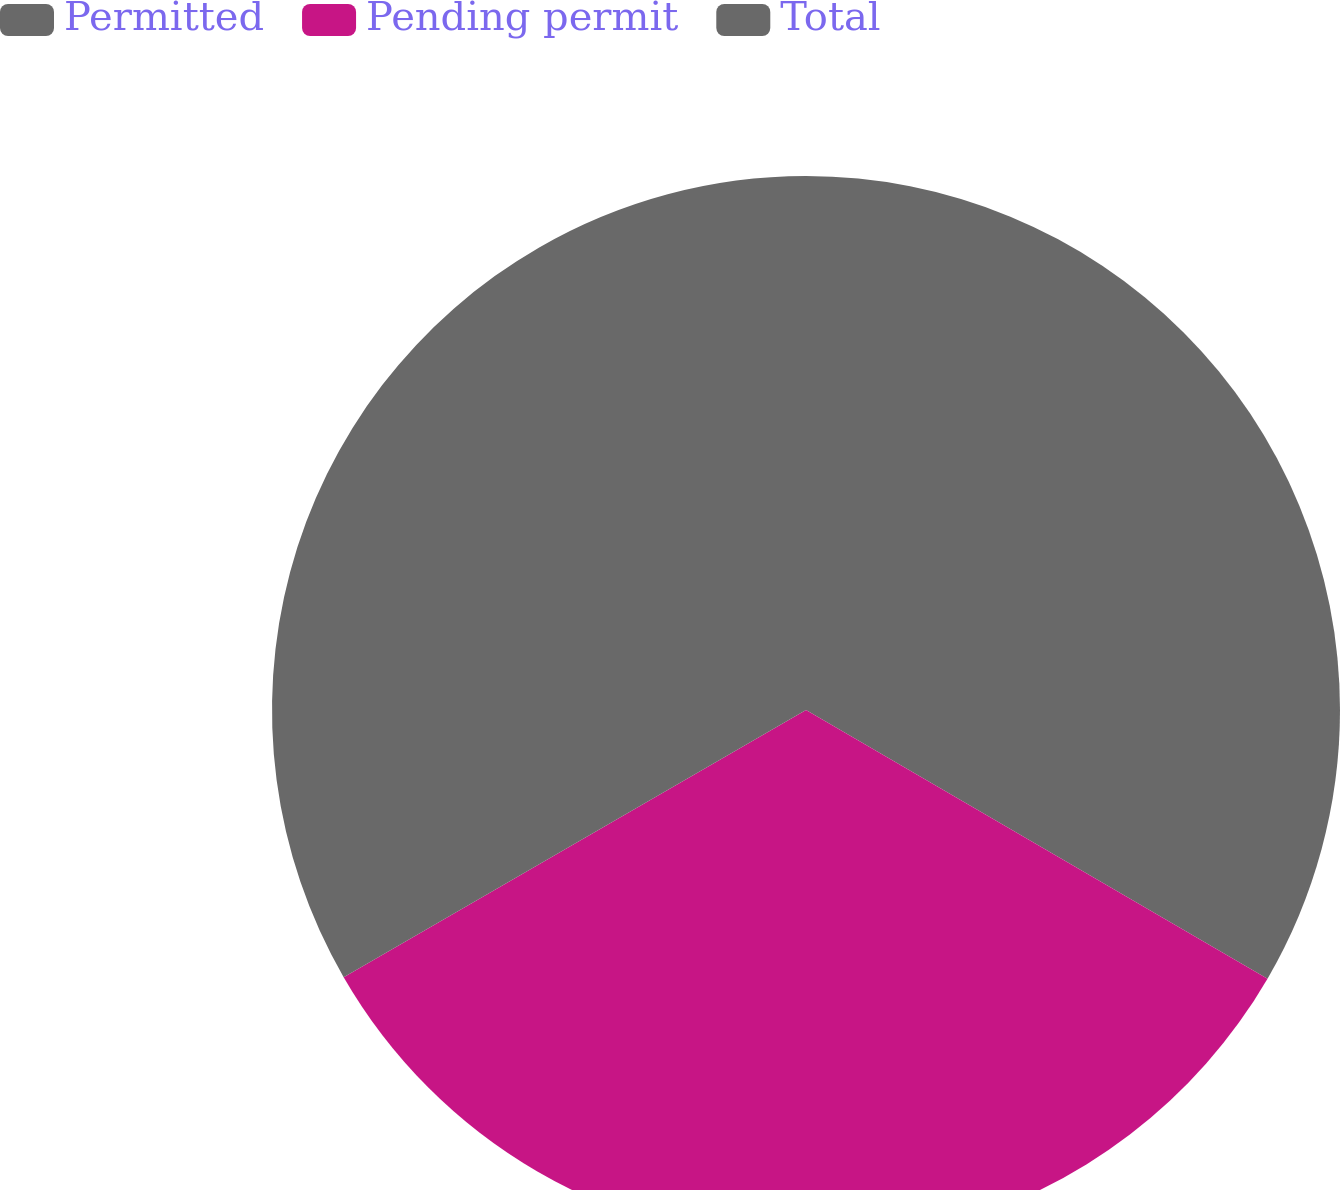Convert chart. <chart><loc_0><loc_0><loc_500><loc_500><pie_chart><fcel>Permitted<fcel>Pending permit<fcel>Total<nl><fcel>33.39%<fcel>33.27%<fcel>33.34%<nl></chart> 